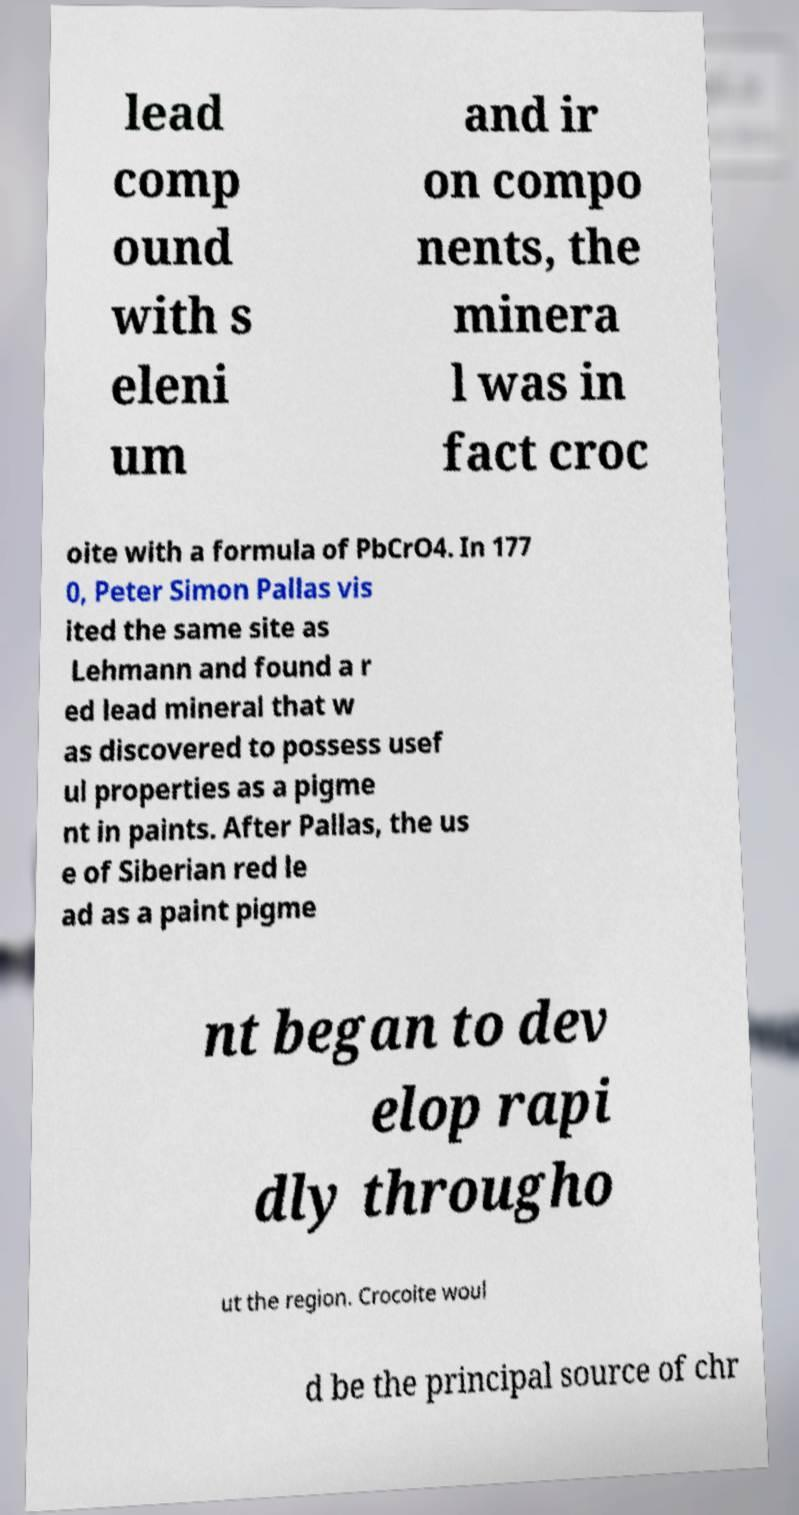Could you extract and type out the text from this image? lead comp ound with s eleni um and ir on compo nents, the minera l was in fact croc oite with a formula of PbCrO4. In 177 0, Peter Simon Pallas vis ited the same site as Lehmann and found a r ed lead mineral that w as discovered to possess usef ul properties as a pigme nt in paints. After Pallas, the us e of Siberian red le ad as a paint pigme nt began to dev elop rapi dly througho ut the region. Crocoite woul d be the principal source of chr 